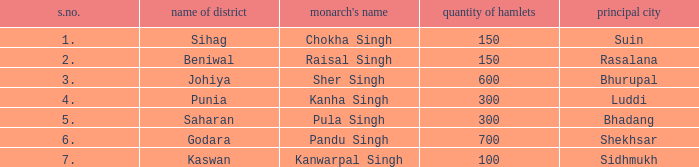What ruler has an s. number exceeding 1 and a total of 600 settlements? Sher Singh. 